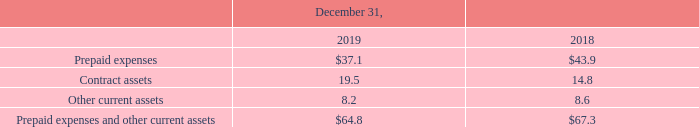Prepaid Expenses and Other Current Assets
Prepaid expenses and other current assets consist of the following (in millions):
Contract Assets
A contract asset represents our expectation of receiving consideration in exchange for products or services that we have transferred to our client. Contract assets and liabilities, or deferred revenues, are determined and presented on a net basis at the contract level since the rights and obligations in a contract with a client are interdependent. In contrast, a receivable is our right to consideration that is unconditional except for the passage of time required before payment of that consideration is due. The difference in timing of revenue recognition, billings and cash collections results in billed accounts receivable, unbilled receivables, contract assets and deferred revenues from client advances and deposits. We account for receivables in accordance with ASC Topic 310, Receivables (“ASC 310”), and assess both contract assets and receivables for impairment in accordance with ASC 310. There were no impairment charges related to contract assets for the years ended December 31, 2019 and 2018.
Our short-term contract assets are included in Prepaid expenses and other current assets in our Consolidated Balance Sheets. Our long-term contract assets are included in Other non-current assets in our Consolidated Balance Sheets. Refer to Note 11 — Other Non-Current Assets.
What does a contract asset represent to the company? Our expectation of receiving consideration in exchange for products or services that we have transferred to our client. What were the prepaid expenses in 2018?
Answer scale should be: million. 43.9. What were the Other current assets in 2019?
Answer scale should be: million. 8.2. What was the change in contract assets between 2018 and 2019?
Answer scale should be: million. 19.5-14.8
Answer: 4.7. How many years did prepaid expenses exceed $40.0 million?
Answer scale should be: million. 2018
Answer: 1. What was the percentage change in Other current assets between 2018 and 2019?
Answer scale should be: percent. (8.2-8.6)/8.6
Answer: -4.65. 